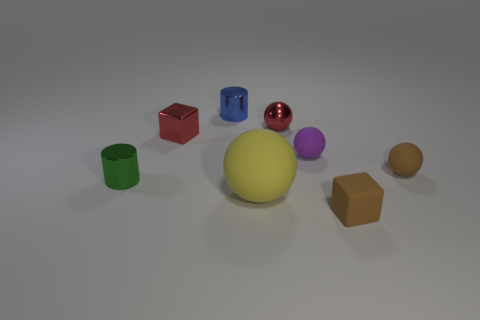There is a tiny shiny cylinder that is in front of the brown matte thing behind the large sphere; what color is it?
Ensure brevity in your answer.  Green. The cylinder that is the same size as the green shiny thing is what color?
Keep it short and to the point. Blue. How many tiny things are either green rubber cylinders or green cylinders?
Your response must be concise. 1. Are there more tiny blocks that are left of the tiny blue cylinder than yellow things to the left of the metal cube?
Your answer should be compact. Yes. What number of other objects are there of the same size as the yellow rubber thing?
Offer a very short reply. 0. Is the material of the cylinder behind the small metal ball the same as the large yellow object?
Give a very brief answer. No. What number of other objects are the same color as the small shiny block?
Your response must be concise. 1. How many other things are the same shape as the large yellow matte thing?
Ensure brevity in your answer.  3. There is a small brown object that is in front of the brown rubber sphere; is it the same shape as the matte object that is on the left side of the small purple rubber ball?
Provide a short and direct response. No. Is the number of tiny red blocks to the right of the metal cube the same as the number of small purple objects that are behind the large object?
Offer a terse response. No. 